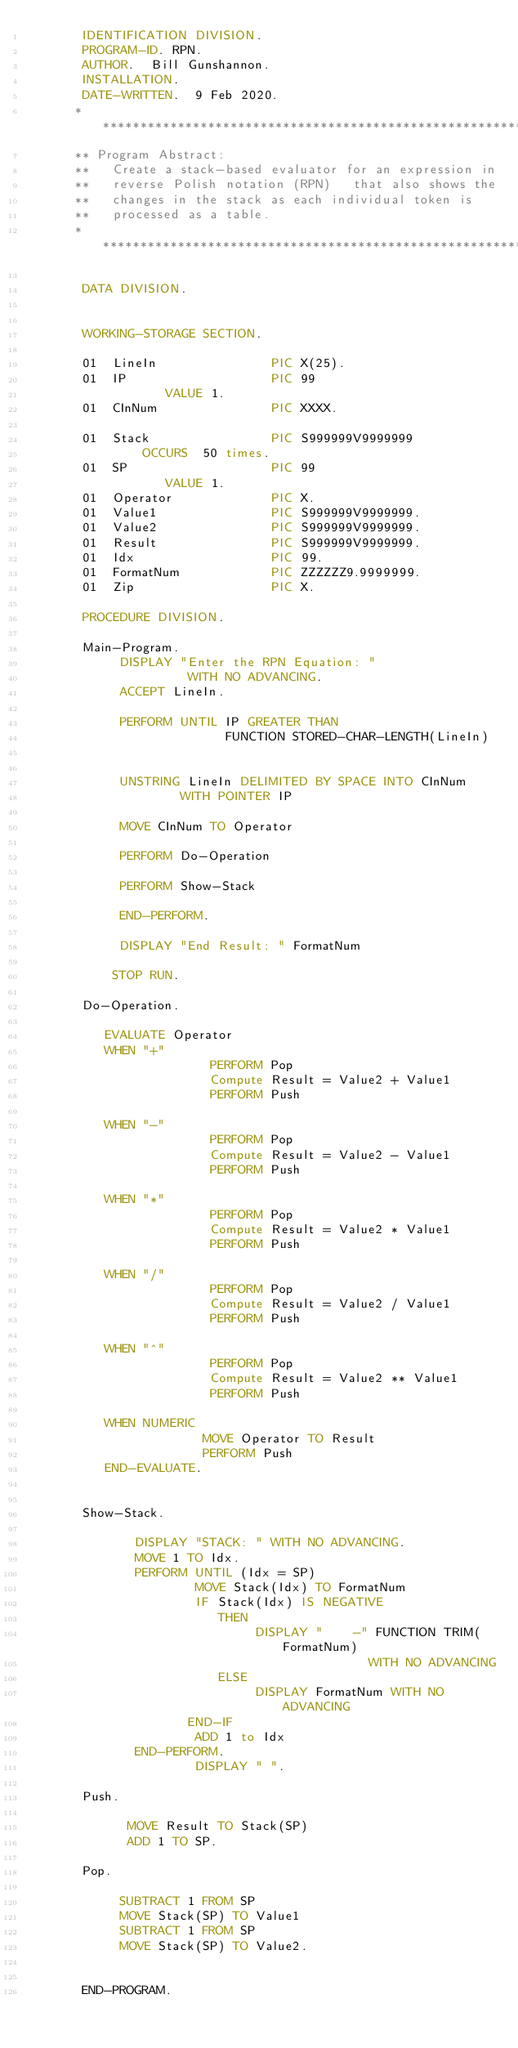Convert code to text. <code><loc_0><loc_0><loc_500><loc_500><_COBOL_>       IDENTIFICATION DIVISION.
       PROGRAM-ID. RPN.
       AUTHOR.  Bill Gunshannon.
       INSTALLATION.
       DATE-WRITTEN.  9 Feb 2020.
      ************************************************************
      ** Program Abstract:
      **   Create a stack-based evaluator for an expression in
      **   reverse Polish notation (RPN)   that also shows the
      **   changes in the stack as each individual token is
      **   processed as a table.
      ************************************************************

       DATA DIVISION.


       WORKING-STORAGE SECTION.

       01  LineIn               PIC X(25).
       01  IP                   PIC 99
                  VALUE 1.
       01  CInNum               PIC XXXX.

       01  Stack                PIC S999999V9999999
               OCCURS  50 times.
       01  SP                   PIC 99
                  VALUE 1.
       01  Operator             PIC X.
       01  Value1               PIC S999999V9999999.
       01  Value2               PIC S999999V9999999.
       01  Result               PIC S999999V9999999.
       01  Idx                  PIC 99.
       01  FormatNum            PIC ZZZZZZ9.9999999.
       01  Zip                  PIC X.

       PROCEDURE DIVISION.

       Main-Program.
            DISPLAY "Enter the RPN Equation: "
                     WITH NO ADVANCING.
            ACCEPT LineIn.

            PERFORM UNTIL IP GREATER THAN
                          FUNCTION STORED-CHAR-LENGTH(LineIn)


            UNSTRING LineIn DELIMITED BY SPACE INTO CInNum
                    WITH POINTER IP

            MOVE CInNum TO Operator

            PERFORM Do-Operation

            PERFORM Show-Stack

            END-PERFORM.

            DISPLAY "End Result: " FormatNum

           STOP RUN.

       Do-Operation.

          EVALUATE Operator
          WHEN "+"
                        PERFORM Pop
                        Compute Result = Value2 + Value1
                        PERFORM Push

          WHEN "-"
                        PERFORM Pop
                        Compute Result = Value2 - Value1
                        PERFORM Push

          WHEN "*"
                        PERFORM Pop
                        Compute Result = Value2 * Value1
                        PERFORM Push

          WHEN "/"
                        PERFORM Pop
                        Compute Result = Value2 / Value1
                        PERFORM Push

          WHEN "^"
                        PERFORM Pop
                        Compute Result = Value2 ** Value1
                        PERFORM Push

          WHEN NUMERIC
                       MOVE Operator TO Result
                       PERFORM Push
          END-EVALUATE.


       Show-Stack.

              DISPLAY "STACK: " WITH NO ADVANCING.
              MOVE 1 TO Idx.
              PERFORM UNTIL (Idx = SP)
                      MOVE Stack(Idx) TO FormatNum
                      IF Stack(Idx) IS NEGATIVE
                         THEN
                              DISPLAY "    -" FUNCTION TRIM(FormatNum)
                                             WITH NO ADVANCING
                         ELSE
                              DISPLAY FormatNum WITH NO ADVANCING
                     END-IF
                      ADD 1 to Idx
              END-PERFORM.
                      DISPLAY " ".

       Push.

             MOVE Result TO Stack(SP)
             ADD 1 TO SP.

       Pop.

            SUBTRACT 1 FROM SP
            MOVE Stack(SP) TO Value1
            SUBTRACT 1 FROM SP
            MOVE Stack(SP) TO Value2.


       END-PROGRAM.
</code> 